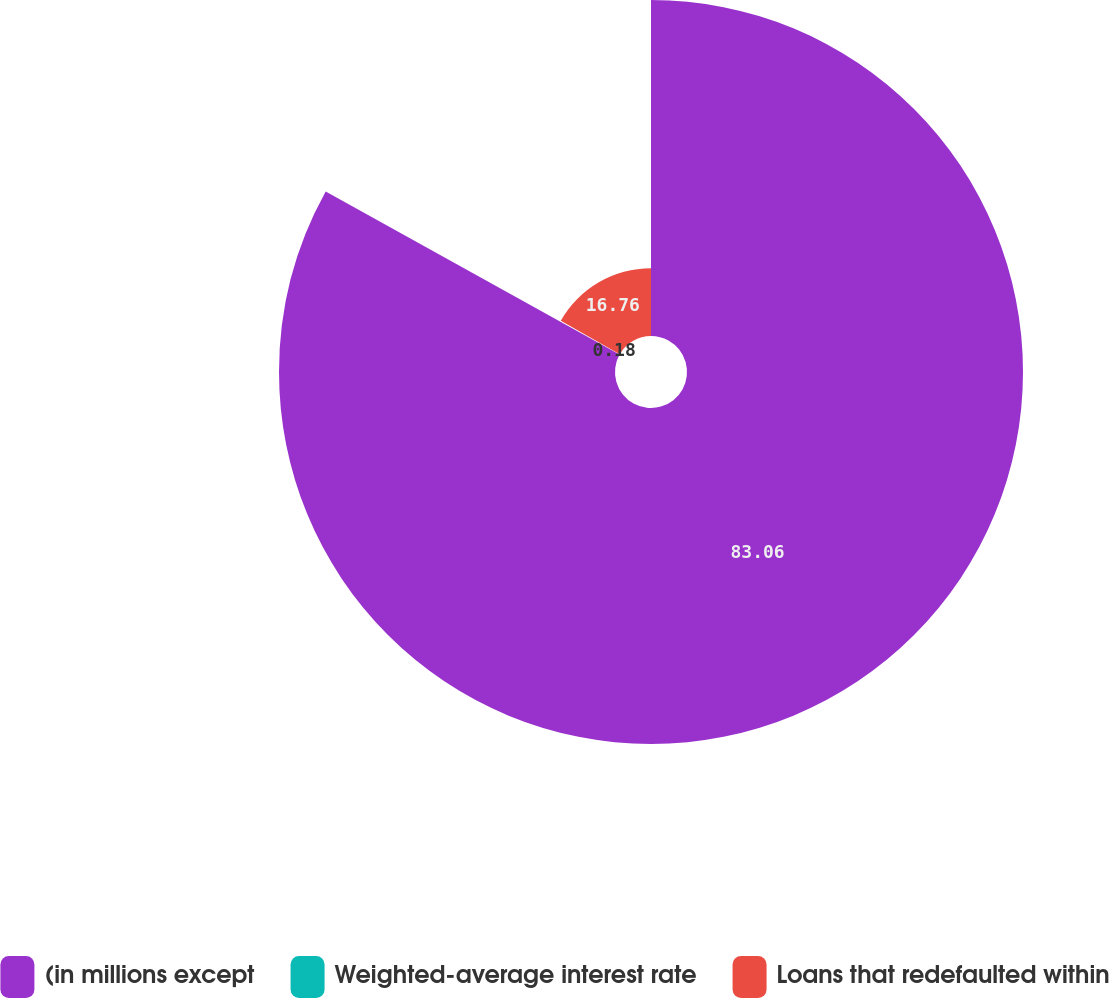<chart> <loc_0><loc_0><loc_500><loc_500><pie_chart><fcel>(in millions except<fcel>Weighted-average interest rate<fcel>Loans that redefaulted within<nl><fcel>83.06%<fcel>0.18%<fcel>16.76%<nl></chart> 